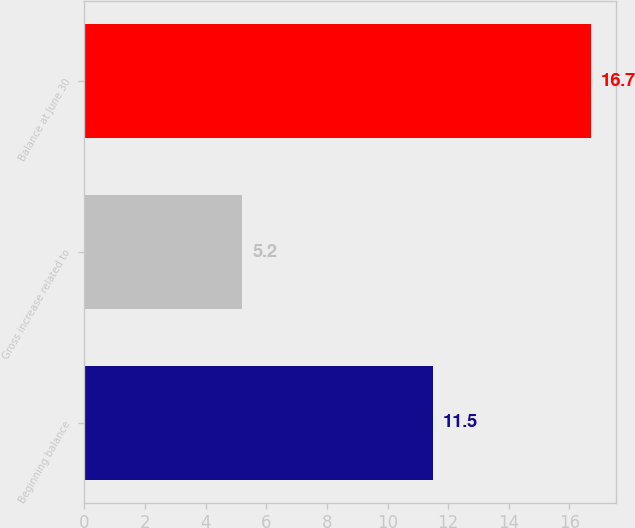<chart> <loc_0><loc_0><loc_500><loc_500><bar_chart><fcel>Beginning balance<fcel>Gross increase related to<fcel>Balance at June 30<nl><fcel>11.5<fcel>5.2<fcel>16.7<nl></chart> 